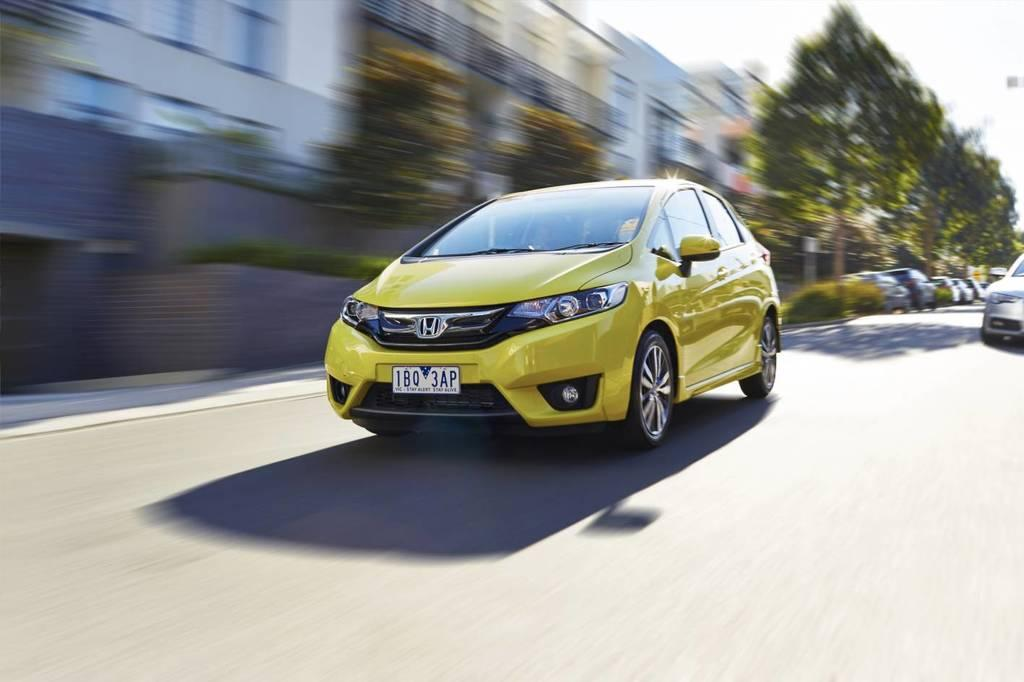What is the main subject of the image? The main subject of the image is a car moving on the road. What can be seen in the background of the image? There are trees and buildings in the background of the image. How is the background of the image depicted? The background of the image is blurred. What type of drink is being advertised on the car in the image? There is no drink being advertised on the car in the image. How is the car measuring the distance it travels in the image? The car is not measuring the distance it travels in the image; it is simply moving on the road. 